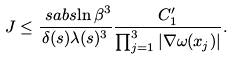Convert formula to latex. <formula><loc_0><loc_0><loc_500><loc_500>J & \leq \frac { \ s a b s { \ln \beta } ^ { 3 } } { \delta ( s ) \lambda ( s ) ^ { 3 } } \frac { C _ { 1 } ^ { \prime } } { \prod _ { j = 1 } ^ { 3 } | \nabla \omega ( x _ { j } ) | } .</formula> 